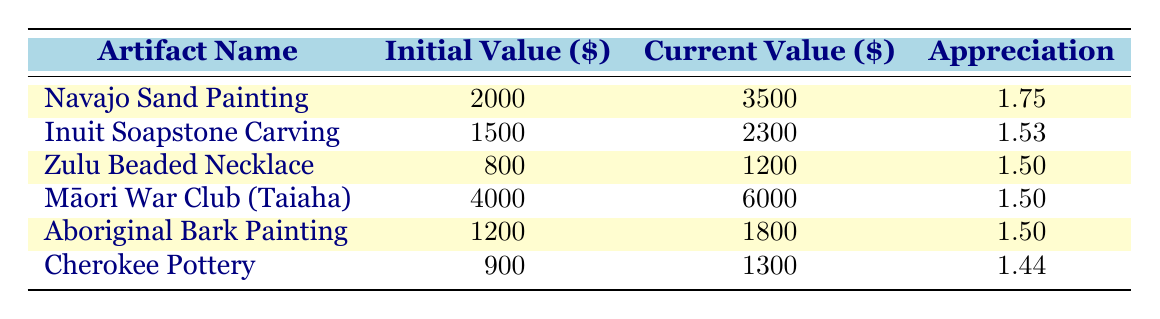What is the current value of the Māori War Club (Taiaha)? The table lists the current value for the Māori War Club (Taiaha) directly in the corresponding row. It shows as 6000.
Answer: 6000 What is the initial value of the Inuit Soapstone Carving? The table indicates that the initial value for the Inuit Soapstone Carving is located in its respective row, which is 1500.
Answer: 1500 Which artifact has the highest appreciation? To determine this, we look for the highest value in the Appreciation column. The Navajo Sand Painting shows an appreciation of 1.75, which is higher than all others listed.
Answer: Navajo Sand Painting Is the current value of the Zulu Beaded Necklace greater than the initial value? A comparison of the values shows the current value of the Zulu Beaded Necklace is 1200, while the initial value is 800. Since 1200 is greater than 800, the statement is true.
Answer: Yes What is the average appreciation of all the artifacts? To find the average appreciation, we sum up all the appreciation values (1.75 + 1.53 + 1.50 + 1.50 + 1.50 + 1.44 = 9.22) and then divide by the number of artifacts (6). Thus, the average is 9.22/6 = 1.54.
Answer: 1.54 Which artifacts are valued above 2000 currently? We check each current value against 2000. The Navajo Sand Painting (3500) and Māori War Club (6000) are above 2000, hence both qualify as artifacts valued higher.
Answer: Navajo Sand Painting, Māori War Club (Taiaha) How much more is the current value of the Aboriginal Bark Painting compared to its initial value? To find the difference, we subtract the initial value (1200) from the current value (1800): 1800 - 1200 = 600. Thus, the current value is 600 more than the initial value.
Answer: 600 Which artifact has the lowest initial value? We examine the Initial Value column to find the smallest number. The Zulu Beaded Necklace has an initial value of 800, making it the artifact with the lowest initial value.
Answer: Zulu Beaded Necklace Is there any artifact from 2019 or later with an appreciation equal to or greater than 1.5? The artifacts from 2019 (Māori War Club) and later (Aboriginal Bark Painting) both have appreciations (1.50). Thus, the statement is true as they meet the criteria.
Answer: Yes What is the difference between the highest current value and the lowest current value? We identify the highest current value (Māori War Club at 6000) and the lowest current value (Zulu Beaded Necklace at 1200). The difference is 6000 - 1200 = 4800.
Answer: 4800 